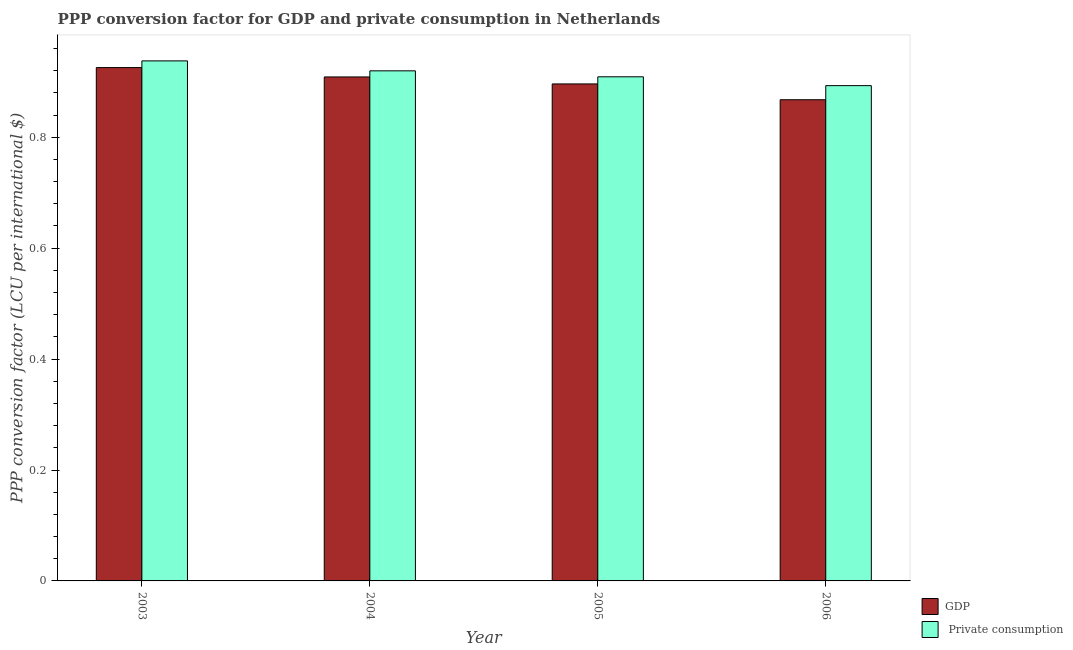What is the label of the 1st group of bars from the left?
Make the answer very short. 2003. In how many cases, is the number of bars for a given year not equal to the number of legend labels?
Make the answer very short. 0. What is the ppp conversion factor for private consumption in 2005?
Your response must be concise. 0.91. Across all years, what is the maximum ppp conversion factor for private consumption?
Your answer should be very brief. 0.94. Across all years, what is the minimum ppp conversion factor for gdp?
Provide a succinct answer. 0.87. In which year was the ppp conversion factor for gdp maximum?
Give a very brief answer. 2003. In which year was the ppp conversion factor for gdp minimum?
Ensure brevity in your answer.  2006. What is the total ppp conversion factor for private consumption in the graph?
Give a very brief answer. 3.66. What is the difference between the ppp conversion factor for gdp in 2003 and that in 2004?
Your response must be concise. 0.02. What is the difference between the ppp conversion factor for private consumption in 2005 and the ppp conversion factor for gdp in 2006?
Ensure brevity in your answer.  0.02. What is the average ppp conversion factor for gdp per year?
Make the answer very short. 0.9. In how many years, is the ppp conversion factor for gdp greater than 0.32 LCU?
Your answer should be very brief. 4. What is the ratio of the ppp conversion factor for gdp in 2004 to that in 2006?
Provide a succinct answer. 1.05. What is the difference between the highest and the second highest ppp conversion factor for private consumption?
Give a very brief answer. 0.02. What is the difference between the highest and the lowest ppp conversion factor for gdp?
Make the answer very short. 0.06. In how many years, is the ppp conversion factor for private consumption greater than the average ppp conversion factor for private consumption taken over all years?
Provide a succinct answer. 2. Is the sum of the ppp conversion factor for gdp in 2003 and 2006 greater than the maximum ppp conversion factor for private consumption across all years?
Your response must be concise. Yes. What does the 2nd bar from the left in 2003 represents?
Provide a short and direct response.  Private consumption. What does the 1st bar from the right in 2004 represents?
Make the answer very short.  Private consumption. How many bars are there?
Your answer should be compact. 8. Are all the bars in the graph horizontal?
Your answer should be very brief. No. Are the values on the major ticks of Y-axis written in scientific E-notation?
Your answer should be very brief. No. Does the graph contain any zero values?
Provide a short and direct response. No. Where does the legend appear in the graph?
Ensure brevity in your answer.  Bottom right. What is the title of the graph?
Offer a very short reply. PPP conversion factor for GDP and private consumption in Netherlands. What is the label or title of the X-axis?
Make the answer very short. Year. What is the label or title of the Y-axis?
Make the answer very short. PPP conversion factor (LCU per international $). What is the PPP conversion factor (LCU per international $) of GDP in 2003?
Your response must be concise. 0.93. What is the PPP conversion factor (LCU per international $) of  Private consumption in 2003?
Give a very brief answer. 0.94. What is the PPP conversion factor (LCU per international $) in GDP in 2004?
Offer a terse response. 0.91. What is the PPP conversion factor (LCU per international $) in  Private consumption in 2004?
Offer a very short reply. 0.92. What is the PPP conversion factor (LCU per international $) in GDP in 2005?
Give a very brief answer. 0.9. What is the PPP conversion factor (LCU per international $) in  Private consumption in 2005?
Provide a succinct answer. 0.91. What is the PPP conversion factor (LCU per international $) in GDP in 2006?
Ensure brevity in your answer.  0.87. What is the PPP conversion factor (LCU per international $) of  Private consumption in 2006?
Ensure brevity in your answer.  0.89. Across all years, what is the maximum PPP conversion factor (LCU per international $) of GDP?
Give a very brief answer. 0.93. Across all years, what is the maximum PPP conversion factor (LCU per international $) in  Private consumption?
Your answer should be very brief. 0.94. Across all years, what is the minimum PPP conversion factor (LCU per international $) of GDP?
Provide a succinct answer. 0.87. Across all years, what is the minimum PPP conversion factor (LCU per international $) of  Private consumption?
Your response must be concise. 0.89. What is the total PPP conversion factor (LCU per international $) in GDP in the graph?
Give a very brief answer. 3.6. What is the total PPP conversion factor (LCU per international $) of  Private consumption in the graph?
Offer a terse response. 3.66. What is the difference between the PPP conversion factor (LCU per international $) in GDP in 2003 and that in 2004?
Ensure brevity in your answer.  0.02. What is the difference between the PPP conversion factor (LCU per international $) in  Private consumption in 2003 and that in 2004?
Offer a terse response. 0.02. What is the difference between the PPP conversion factor (LCU per international $) of GDP in 2003 and that in 2005?
Your answer should be compact. 0.03. What is the difference between the PPP conversion factor (LCU per international $) of  Private consumption in 2003 and that in 2005?
Keep it short and to the point. 0.03. What is the difference between the PPP conversion factor (LCU per international $) in GDP in 2003 and that in 2006?
Ensure brevity in your answer.  0.06. What is the difference between the PPP conversion factor (LCU per international $) in  Private consumption in 2003 and that in 2006?
Offer a very short reply. 0.04. What is the difference between the PPP conversion factor (LCU per international $) in GDP in 2004 and that in 2005?
Make the answer very short. 0.01. What is the difference between the PPP conversion factor (LCU per international $) of  Private consumption in 2004 and that in 2005?
Offer a terse response. 0.01. What is the difference between the PPP conversion factor (LCU per international $) in GDP in 2004 and that in 2006?
Your answer should be very brief. 0.04. What is the difference between the PPP conversion factor (LCU per international $) in  Private consumption in 2004 and that in 2006?
Ensure brevity in your answer.  0.03. What is the difference between the PPP conversion factor (LCU per international $) of GDP in 2005 and that in 2006?
Make the answer very short. 0.03. What is the difference between the PPP conversion factor (LCU per international $) in  Private consumption in 2005 and that in 2006?
Provide a succinct answer. 0.02. What is the difference between the PPP conversion factor (LCU per international $) of GDP in 2003 and the PPP conversion factor (LCU per international $) of  Private consumption in 2004?
Make the answer very short. 0.01. What is the difference between the PPP conversion factor (LCU per international $) in GDP in 2003 and the PPP conversion factor (LCU per international $) in  Private consumption in 2005?
Provide a succinct answer. 0.02. What is the difference between the PPP conversion factor (LCU per international $) in GDP in 2003 and the PPP conversion factor (LCU per international $) in  Private consumption in 2006?
Your answer should be compact. 0.03. What is the difference between the PPP conversion factor (LCU per international $) of GDP in 2004 and the PPP conversion factor (LCU per international $) of  Private consumption in 2005?
Provide a succinct answer. -0. What is the difference between the PPP conversion factor (LCU per international $) of GDP in 2004 and the PPP conversion factor (LCU per international $) of  Private consumption in 2006?
Your response must be concise. 0.02. What is the difference between the PPP conversion factor (LCU per international $) of GDP in 2005 and the PPP conversion factor (LCU per international $) of  Private consumption in 2006?
Your answer should be very brief. 0. What is the average PPP conversion factor (LCU per international $) in GDP per year?
Your answer should be very brief. 0.9. What is the average PPP conversion factor (LCU per international $) of  Private consumption per year?
Make the answer very short. 0.91. In the year 2003, what is the difference between the PPP conversion factor (LCU per international $) of GDP and PPP conversion factor (LCU per international $) of  Private consumption?
Your answer should be compact. -0.01. In the year 2004, what is the difference between the PPP conversion factor (LCU per international $) of GDP and PPP conversion factor (LCU per international $) of  Private consumption?
Your answer should be compact. -0.01. In the year 2005, what is the difference between the PPP conversion factor (LCU per international $) of GDP and PPP conversion factor (LCU per international $) of  Private consumption?
Offer a terse response. -0.01. In the year 2006, what is the difference between the PPP conversion factor (LCU per international $) in GDP and PPP conversion factor (LCU per international $) in  Private consumption?
Offer a terse response. -0.03. What is the ratio of the PPP conversion factor (LCU per international $) of GDP in 2003 to that in 2004?
Make the answer very short. 1.02. What is the ratio of the PPP conversion factor (LCU per international $) of  Private consumption in 2003 to that in 2004?
Your answer should be very brief. 1.02. What is the ratio of the PPP conversion factor (LCU per international $) of GDP in 2003 to that in 2005?
Your answer should be very brief. 1.03. What is the ratio of the PPP conversion factor (LCU per international $) in  Private consumption in 2003 to that in 2005?
Provide a short and direct response. 1.03. What is the ratio of the PPP conversion factor (LCU per international $) of GDP in 2003 to that in 2006?
Offer a very short reply. 1.07. What is the ratio of the PPP conversion factor (LCU per international $) of  Private consumption in 2003 to that in 2006?
Provide a short and direct response. 1.05. What is the ratio of the PPP conversion factor (LCU per international $) in GDP in 2004 to that in 2005?
Offer a very short reply. 1.01. What is the ratio of the PPP conversion factor (LCU per international $) in  Private consumption in 2004 to that in 2005?
Keep it short and to the point. 1.01. What is the ratio of the PPP conversion factor (LCU per international $) in GDP in 2004 to that in 2006?
Offer a very short reply. 1.05. What is the ratio of the PPP conversion factor (LCU per international $) of  Private consumption in 2004 to that in 2006?
Provide a short and direct response. 1.03. What is the ratio of the PPP conversion factor (LCU per international $) of GDP in 2005 to that in 2006?
Your response must be concise. 1.03. What is the ratio of the PPP conversion factor (LCU per international $) in  Private consumption in 2005 to that in 2006?
Offer a very short reply. 1.02. What is the difference between the highest and the second highest PPP conversion factor (LCU per international $) in GDP?
Offer a terse response. 0.02. What is the difference between the highest and the second highest PPP conversion factor (LCU per international $) of  Private consumption?
Give a very brief answer. 0.02. What is the difference between the highest and the lowest PPP conversion factor (LCU per international $) of GDP?
Provide a succinct answer. 0.06. What is the difference between the highest and the lowest PPP conversion factor (LCU per international $) in  Private consumption?
Offer a very short reply. 0.04. 